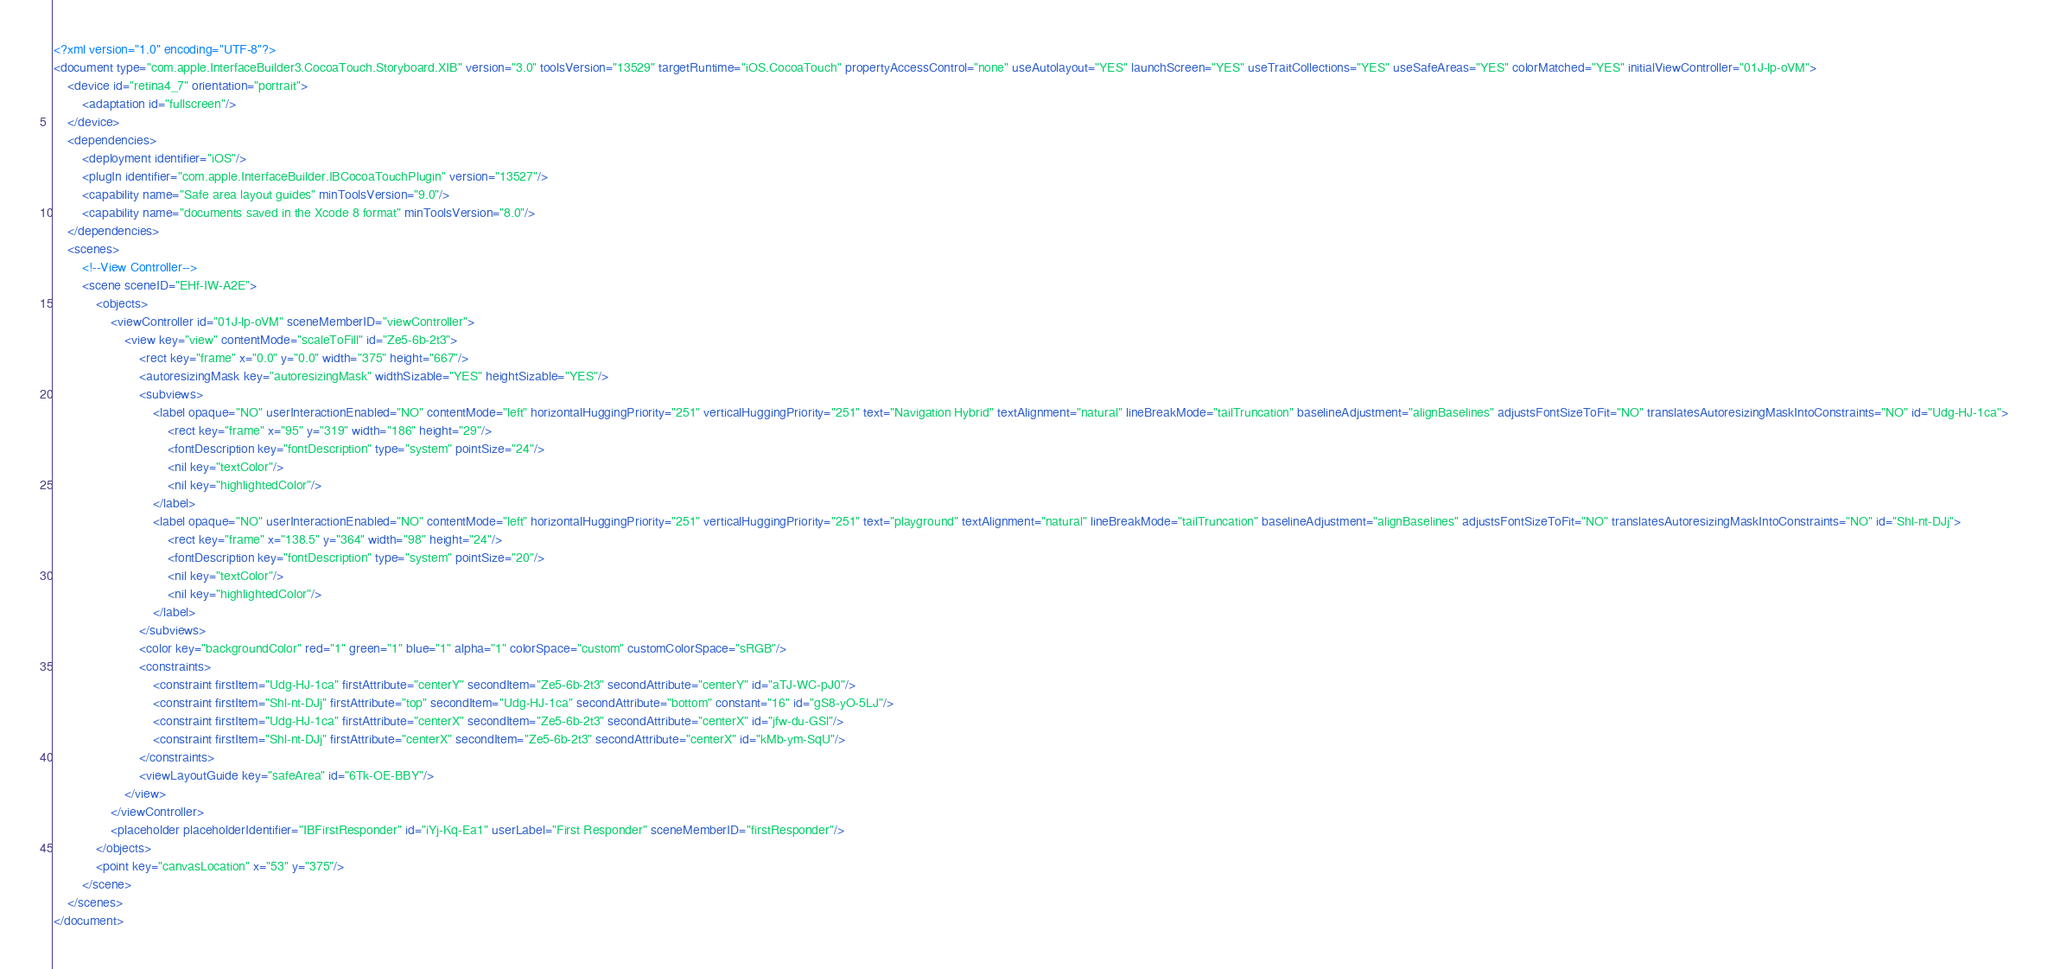Convert code to text. <code><loc_0><loc_0><loc_500><loc_500><_XML_><?xml version="1.0" encoding="UTF-8"?>
<document type="com.apple.InterfaceBuilder3.CocoaTouch.Storyboard.XIB" version="3.0" toolsVersion="13529" targetRuntime="iOS.CocoaTouch" propertyAccessControl="none" useAutolayout="YES" launchScreen="YES" useTraitCollections="YES" useSafeAreas="YES" colorMatched="YES" initialViewController="01J-lp-oVM">
    <device id="retina4_7" orientation="portrait">
        <adaptation id="fullscreen"/>
    </device>
    <dependencies>
        <deployment identifier="iOS"/>
        <plugIn identifier="com.apple.InterfaceBuilder.IBCocoaTouchPlugin" version="13527"/>
        <capability name="Safe area layout guides" minToolsVersion="9.0"/>
        <capability name="documents saved in the Xcode 8 format" minToolsVersion="8.0"/>
    </dependencies>
    <scenes>
        <!--View Controller-->
        <scene sceneID="EHf-IW-A2E">
            <objects>
                <viewController id="01J-lp-oVM" sceneMemberID="viewController">
                    <view key="view" contentMode="scaleToFill" id="Ze5-6b-2t3">
                        <rect key="frame" x="0.0" y="0.0" width="375" height="667"/>
                        <autoresizingMask key="autoresizingMask" widthSizable="YES" heightSizable="YES"/>
                        <subviews>
                            <label opaque="NO" userInteractionEnabled="NO" contentMode="left" horizontalHuggingPriority="251" verticalHuggingPriority="251" text="Navigation Hybrid" textAlignment="natural" lineBreakMode="tailTruncation" baselineAdjustment="alignBaselines" adjustsFontSizeToFit="NO" translatesAutoresizingMaskIntoConstraints="NO" id="Udg-HJ-1ca">
                                <rect key="frame" x="95" y="319" width="186" height="29"/>
                                <fontDescription key="fontDescription" type="system" pointSize="24"/>
                                <nil key="textColor"/>
                                <nil key="highlightedColor"/>
                            </label>
                            <label opaque="NO" userInteractionEnabled="NO" contentMode="left" horizontalHuggingPriority="251" verticalHuggingPriority="251" text="playground" textAlignment="natural" lineBreakMode="tailTruncation" baselineAdjustment="alignBaselines" adjustsFontSizeToFit="NO" translatesAutoresizingMaskIntoConstraints="NO" id="Shl-nt-DJj">
                                <rect key="frame" x="138.5" y="364" width="98" height="24"/>
                                <fontDescription key="fontDescription" type="system" pointSize="20"/>
                                <nil key="textColor"/>
                                <nil key="highlightedColor"/>
                            </label>
                        </subviews>
                        <color key="backgroundColor" red="1" green="1" blue="1" alpha="1" colorSpace="custom" customColorSpace="sRGB"/>
                        <constraints>
                            <constraint firstItem="Udg-HJ-1ca" firstAttribute="centerY" secondItem="Ze5-6b-2t3" secondAttribute="centerY" id="aTJ-WC-pJ0"/>
                            <constraint firstItem="Shl-nt-DJj" firstAttribute="top" secondItem="Udg-HJ-1ca" secondAttribute="bottom" constant="16" id="gS8-yO-5LJ"/>
                            <constraint firstItem="Udg-HJ-1ca" firstAttribute="centerX" secondItem="Ze5-6b-2t3" secondAttribute="centerX" id="jfw-du-GSl"/>
                            <constraint firstItem="Shl-nt-DJj" firstAttribute="centerX" secondItem="Ze5-6b-2t3" secondAttribute="centerX" id="kMb-ym-SqU"/>
                        </constraints>
                        <viewLayoutGuide key="safeArea" id="6Tk-OE-BBY"/>
                    </view>
                </viewController>
                <placeholder placeholderIdentifier="IBFirstResponder" id="iYj-Kq-Ea1" userLabel="First Responder" sceneMemberID="firstResponder"/>
            </objects>
            <point key="canvasLocation" x="53" y="375"/>
        </scene>
    </scenes>
</document>
</code> 